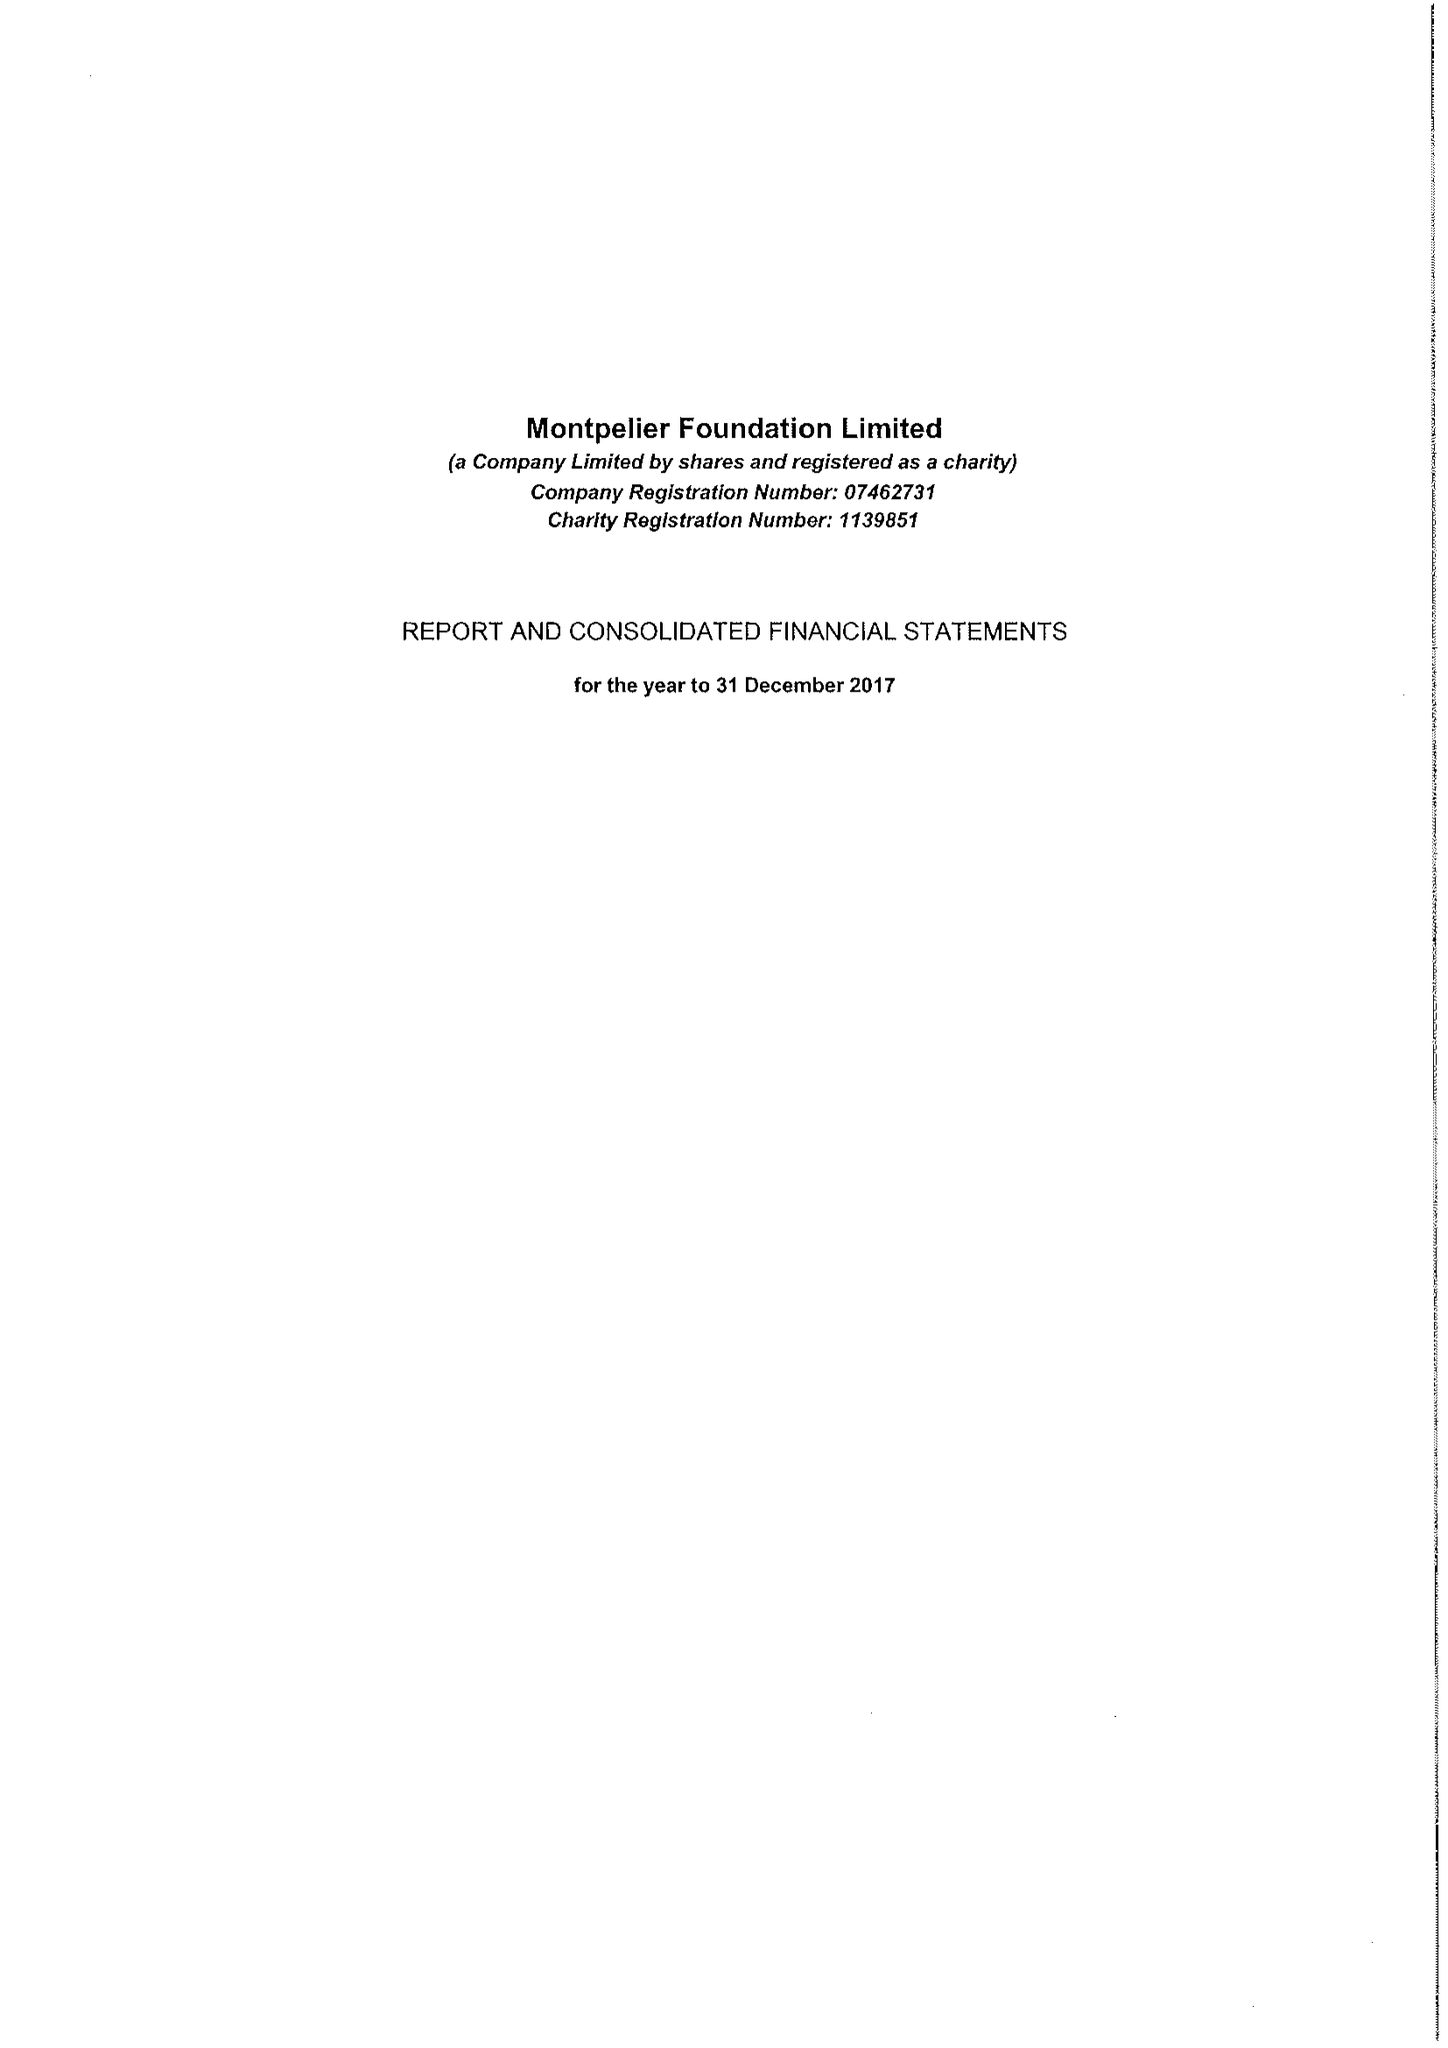What is the value for the address__post_town?
Answer the question using a single word or phrase. LONDON 